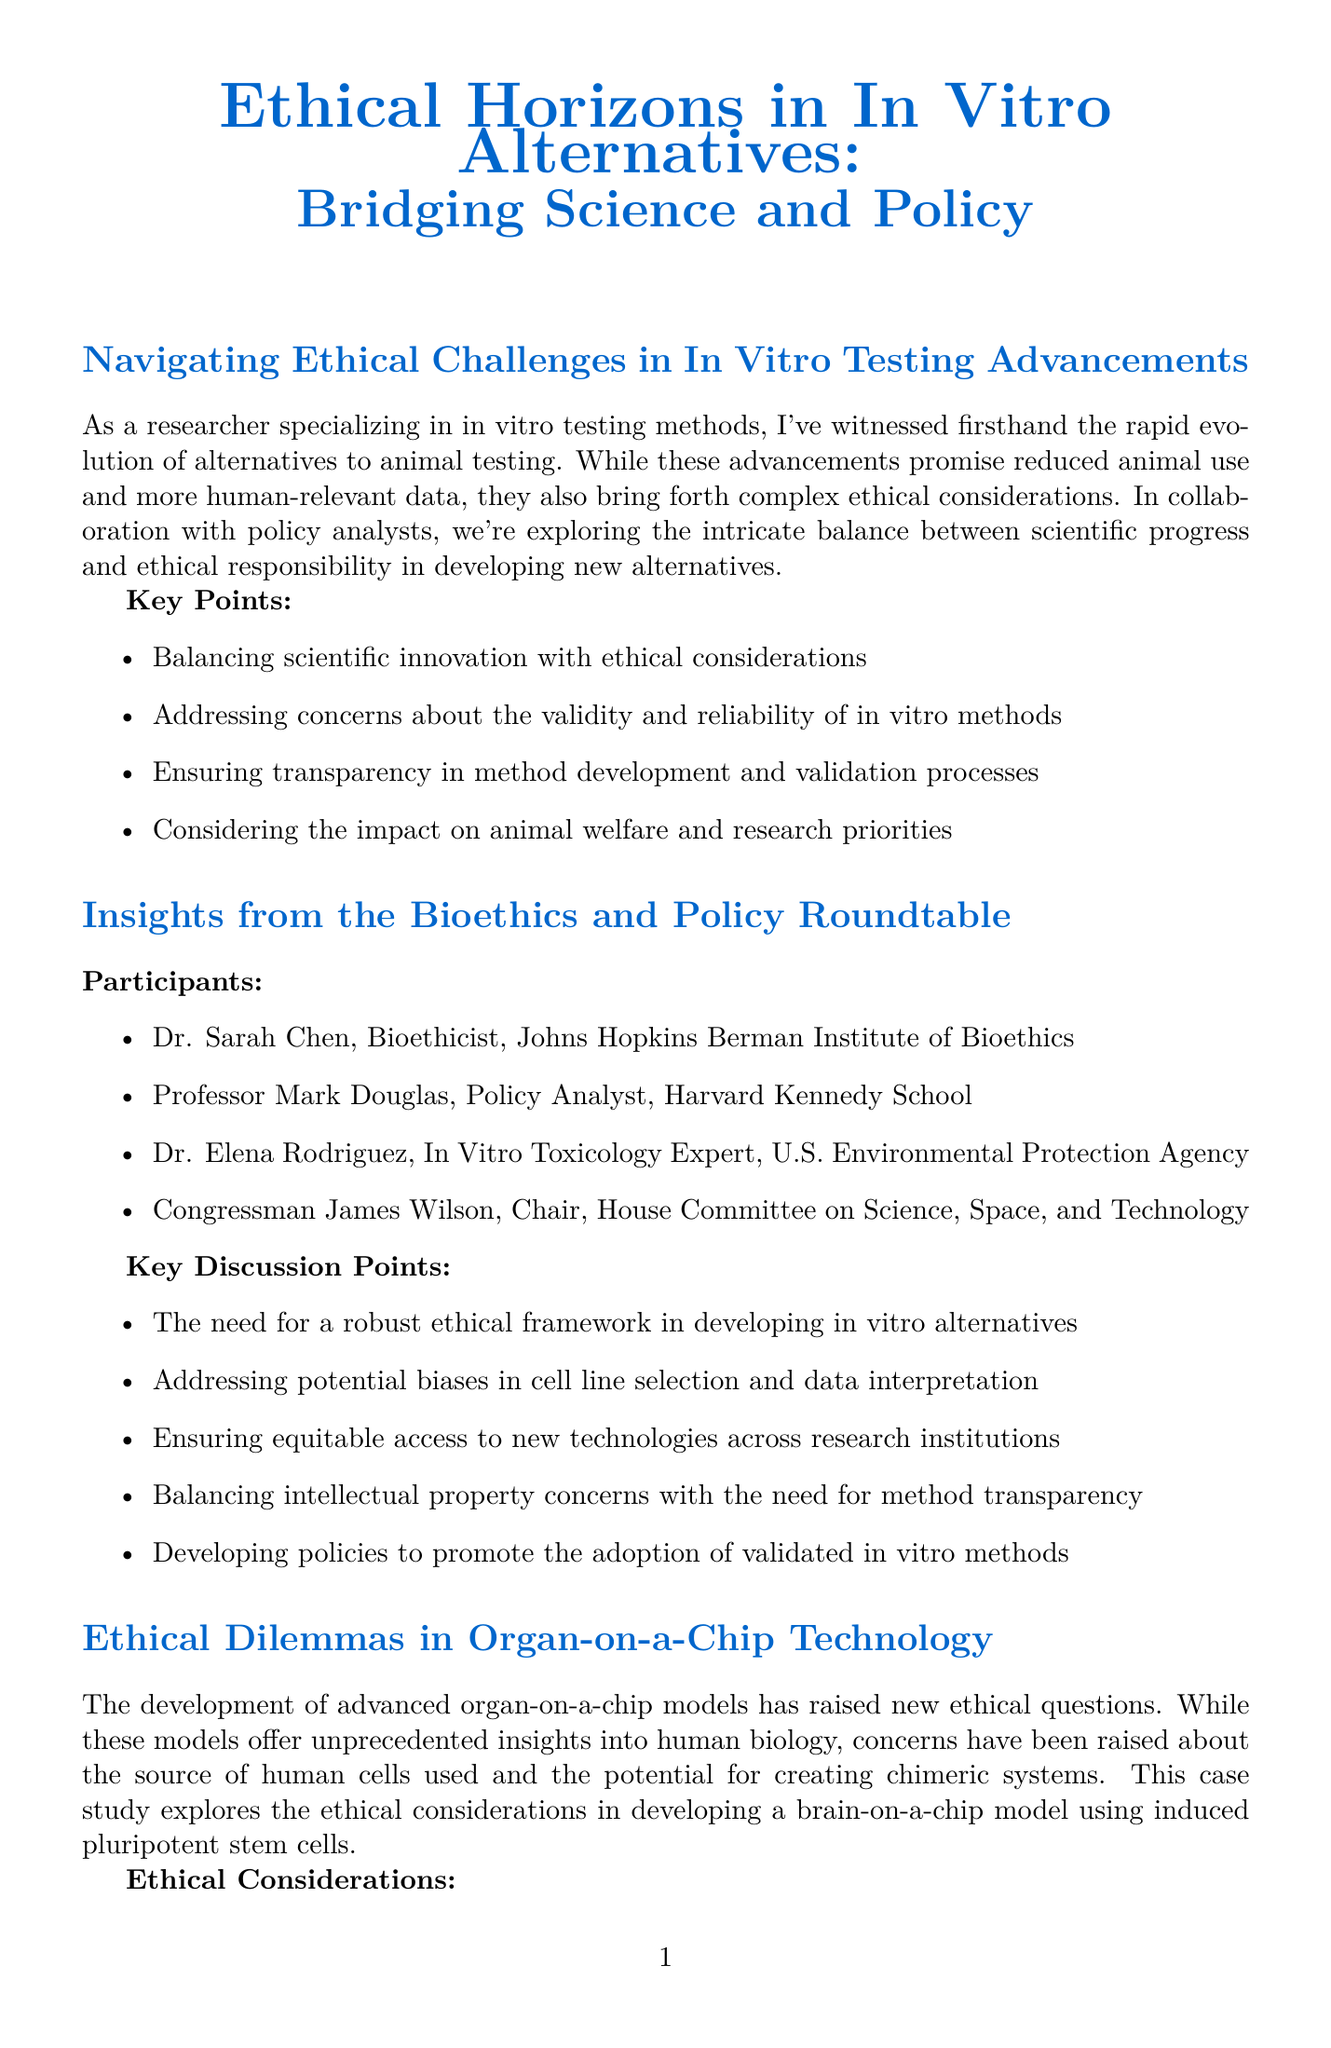What is the title of the main article? The title of the main article is explicitly stated in the document as "Navigating Ethical Challenges in In Vitro Testing Advancements."
Answer: Navigating Ethical Challenges in In Vitro Testing Advancements Who is one of the bioethicists mentioned in the panel discussion? The document lists Dr. Sarah Chen as one of the bioethicists participating in the panel discussion.
Answer: Dr. Sarah Chen What event is scheduled for October 5-6, 2023? The document specifies a workshop titled "Workshop on Ethical Considerations in Advanced In Vitro Models" occurring on these dates.
Answer: Workshop on Ethical Considerations in Advanced In Vitro Models What ethical consideration is associated with organ-on-a-chip technology? The document mentions various ethical considerations, one being "Informed consent for cell donors."
Answer: Informed consent for cell donors How many key discussion points were highlighted in the panel discussion? The document lists five key discussion points from the panel discussion.
Answer: 5 What agency released draft guidance on in vitro data for drug safety assessments? The document explicitly states that the FDA released this draft guidance.
Answer: FDA What is the name of the conference happening in August 2023? The document identifies the conference as the "International Conference on Alternatives and Animal Use in the Life Sciences."
Answer: International Conference on Alternatives and Animal Use in the Life Sciences What is one challenge faced by researchers in the development of in vitro alternatives? The document highlights various challenges, one being "Ensuring the relevance of in vitro models to diverse human populations."
Answer: Ensuring the relevance of in vitro models to diverse human populations 